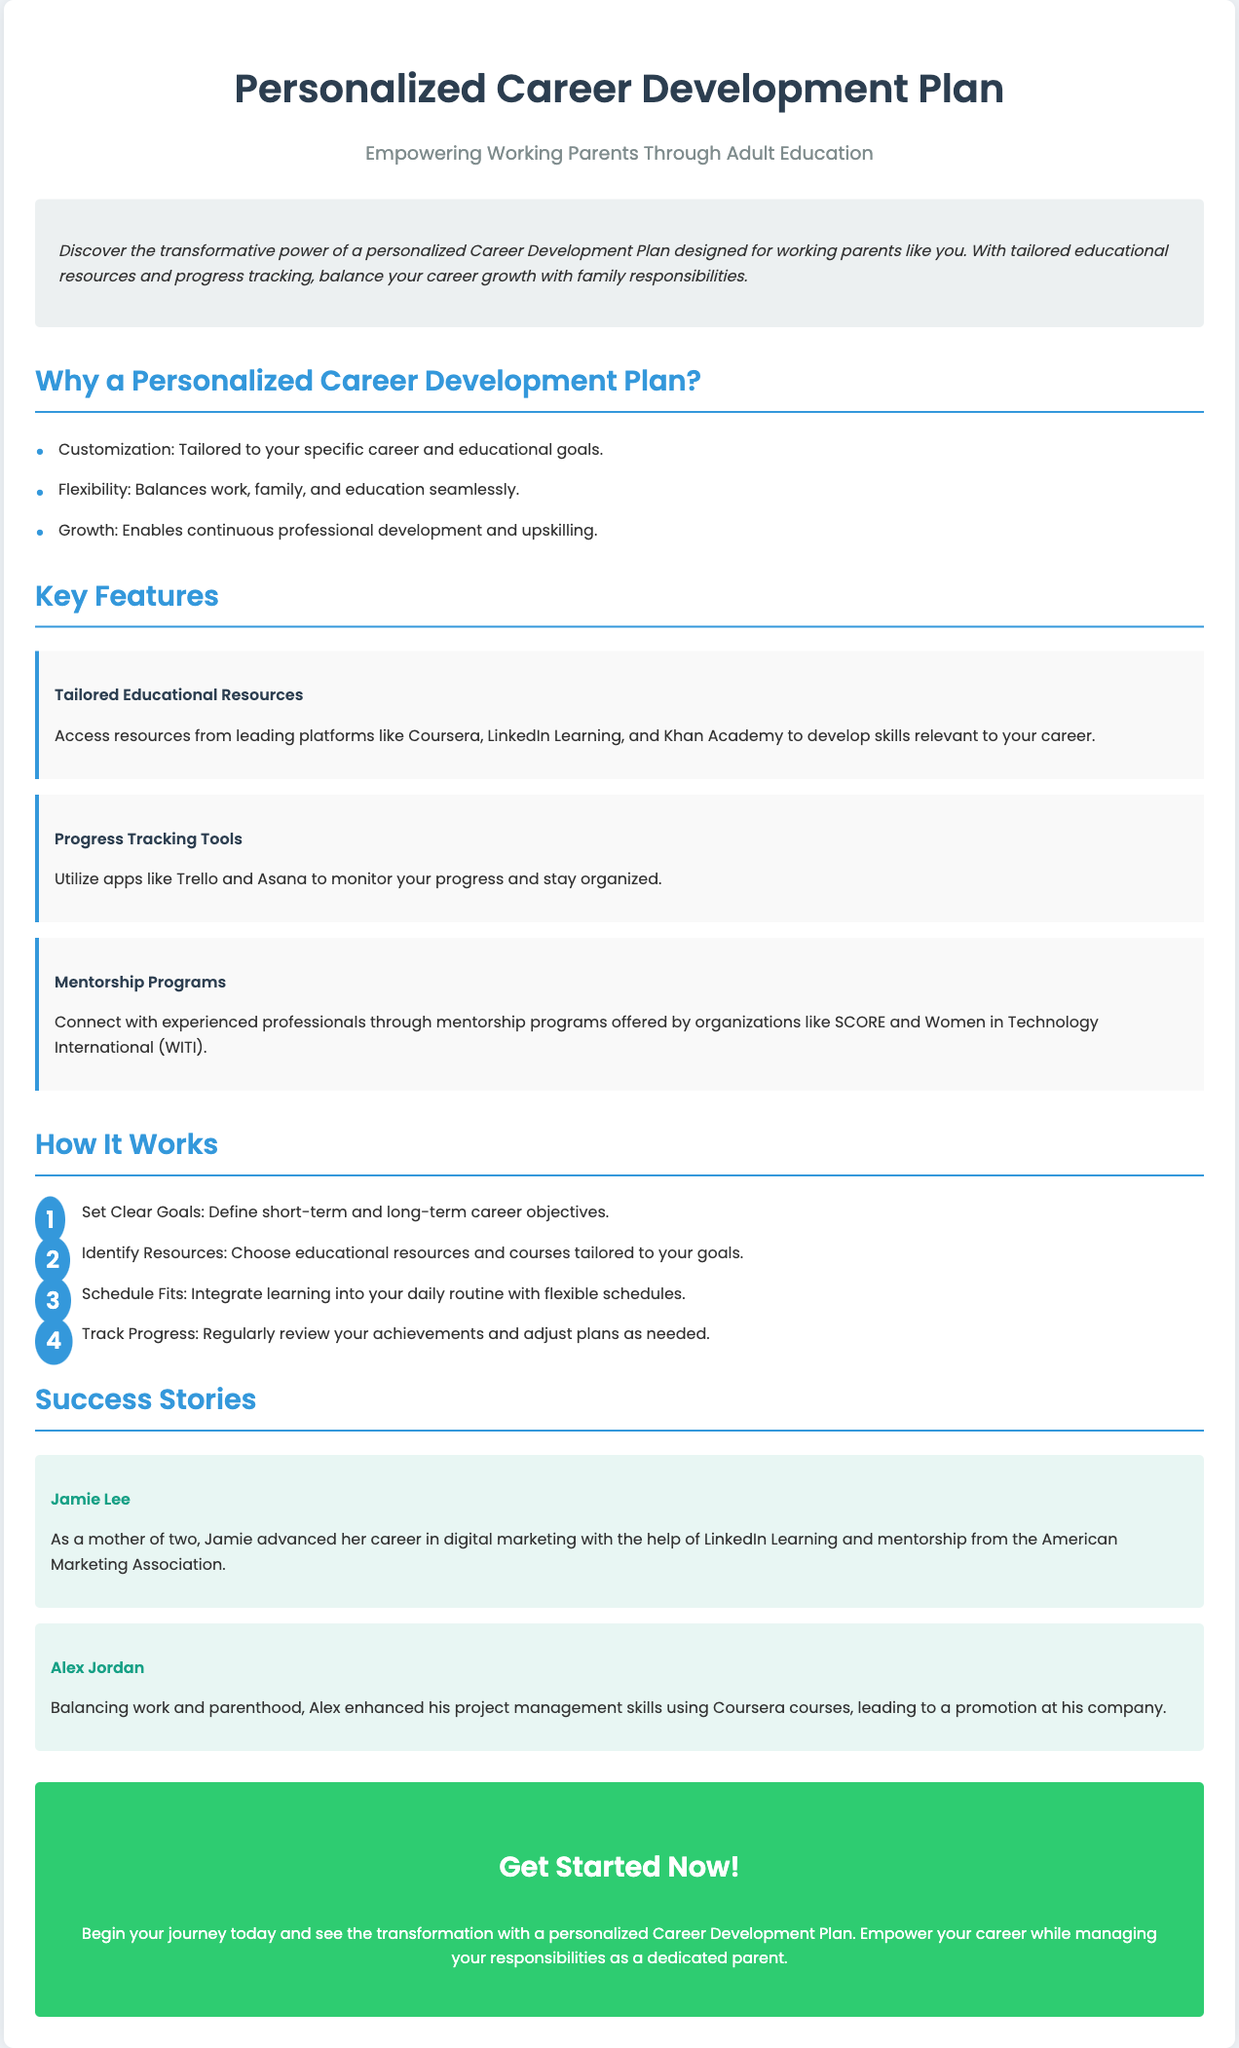What is the target audience for the Career Development Plan? The document indicates that the plan is designed for working parents.
Answer: working parents Which platforms provide the tailored educational resources? The document mentions leading platforms such as Coursera, LinkedIn Learning, and Khan Academy.
Answer: Coursera, LinkedIn Learning, Khan Academy How many steps are outlined in the "How It Works" section? The steps provided in the section total four steps outlined for the process.
Answer: 4 What is the title of the first success story? The first success story features an individual named Jamie Lee.
Answer: Jamie Lee What feature helps in monitoring progress? The document specifies that Progress Tracking Tools assist in this process.
Answer: Progress Tracking Tools What type of programs connect professionals in the document? The document refers to Mentorship Programs that connect experienced professionals.
Answer: Mentorship Programs What color is associated with the call-to-action section? The call-to-action section utilizes a background color of green, specifically mentioned as #2ecc71.
Answer: green Name one organization mentioned for mentorship support. The document lists SCORE and Women in Technology International (WITI) as organizations providing mentorship.
Answer: SCORE 